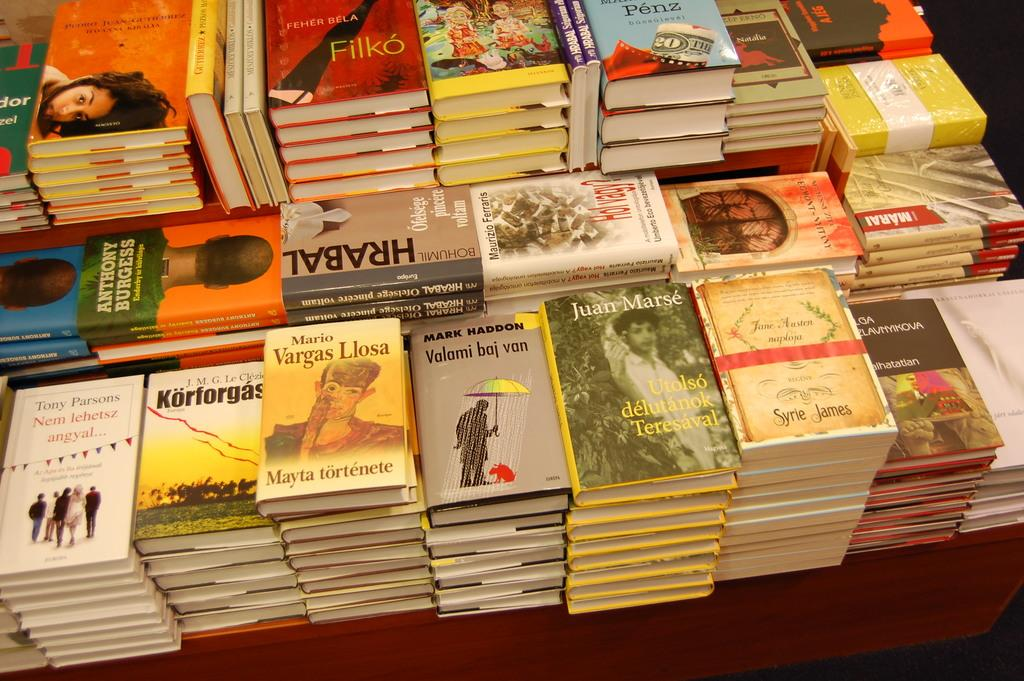<image>
Provide a brief description of the given image. stacks of books with one called 'valomi baj van' 